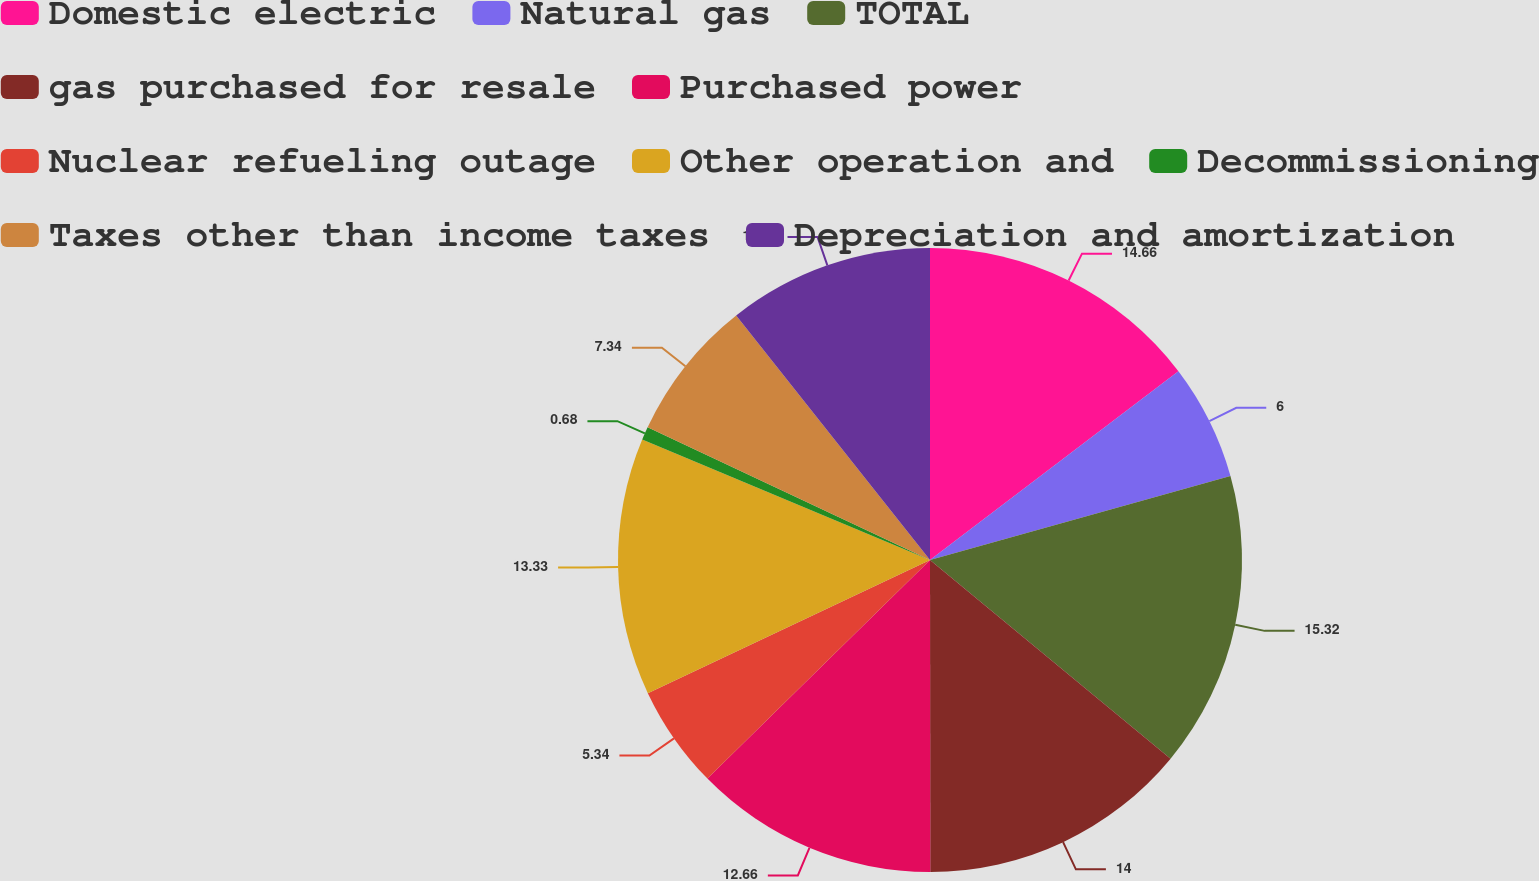Convert chart. <chart><loc_0><loc_0><loc_500><loc_500><pie_chart><fcel>Domestic electric<fcel>Natural gas<fcel>TOTAL<fcel>gas purchased for resale<fcel>Purchased power<fcel>Nuclear refueling outage<fcel>Other operation and<fcel>Decommissioning<fcel>Taxes other than income taxes<fcel>Depreciation and amortization<nl><fcel>14.66%<fcel>6.0%<fcel>15.33%<fcel>14.0%<fcel>12.66%<fcel>5.34%<fcel>13.33%<fcel>0.68%<fcel>7.34%<fcel>10.67%<nl></chart> 